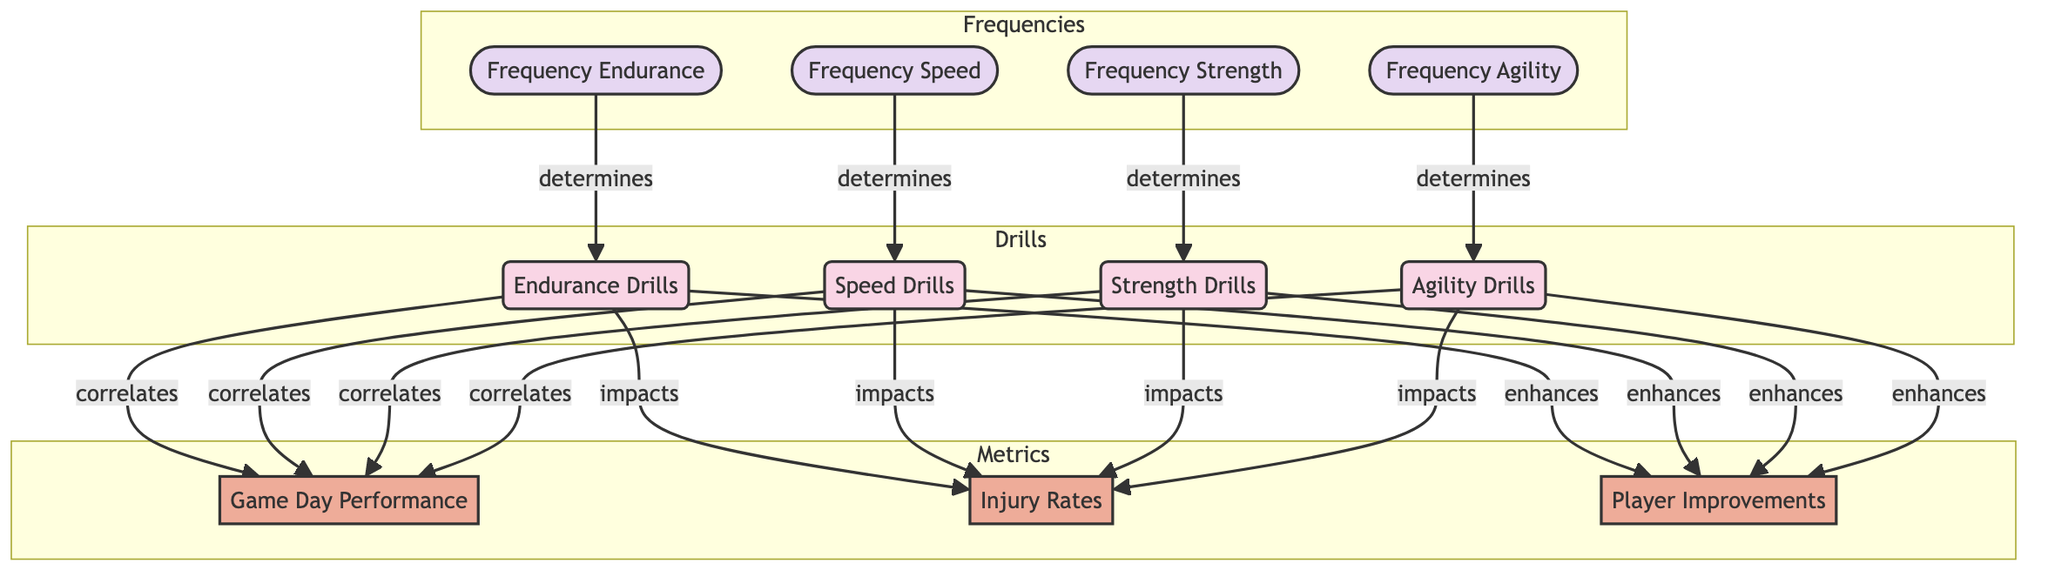What drills are linked to Game Day Performance? The diagram shows that all drills (Endurance Drills, Speed Drills, Strength Drills, and Agility Drills) correlate to Game Day Performance. Therefore, I can identify these connections directly from the edges pointing towards Game Day Performance.
Answer: Endurance Drills, Speed Drills, Strength Drills, Agility Drills How many training drills are there in the diagram? By counting the nodes labeled as "Training Drill", there are four training drills: Endurance Drills, Speed Drills, Strength Drills, and Agility Drills. This gives me a straightforward count of the relevant nodes in the training category.
Answer: 4 Which metric is impacted by Strength Drills? The diagram shows that Strength Drills impacts Injury Rates and enhances Player Improvements. I observe the edges leading from Strength Drills and can see both relationships clearly.
Answer: Injury Rates, Player Improvements What determines the frequency of Agility Drills? The diagram specifies that Frequency Agility determines Agility Drills. This means that the relationship can be traced from the Frequency node directly to the Agility Drills node.
Answer: Frequency Agility Which training drill has the most connections? Each training drill correlates to Game Day Performance, impacts Injury Rates, and enhances Player Improvements. Thus, all drills have an equal number of connections, totaling three connections each.
Answer: Equal connections How many metrics are shown in the diagram? There are three metrics displayed: Game Day Performance, Injury Rates, and Player Improvements. By inspecting the nodes categorized under Metrics, I can count them easily.
Answer: 3 What do Endurance Drills enhance? According to the diagram, Endurance Drills enhance Player Improvements. I can see this relationship illustrated by the edge labeled "enhances" connecting from Endurance Drills to Player Improvements.
Answer: Player Improvements Which frequency influences Speed Drills? The diagram indicates that Frequency Speed determines Speed Drills. This relationship is indicated by the arrow labeled "determines" connecting the Frequency node to the Speed Drills.
Answer: Frequency Speed What is the relationship between Strength Drills and Game Day Performance? The diagram shows that Strength Drills correlate to Game Day Performance, represented by the edge that connects these two nodes with the label "correlates". This clearly defines the nature of their relationship.
Answer: Correlates 